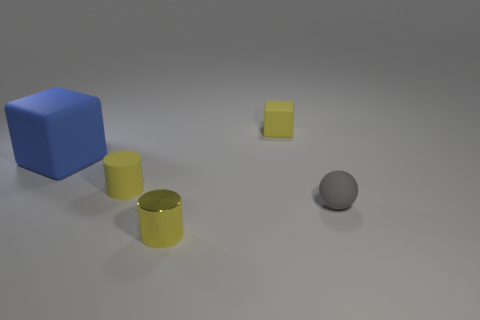The blue matte cube is what size?
Your answer should be very brief. Large. Are there more big things to the left of the tiny gray ball than big yellow cylinders?
Ensure brevity in your answer.  Yes. Are there the same number of tiny shiny things that are in front of the blue rubber block and shiny cylinders in front of the tiny matte ball?
Offer a terse response. Yes. The small thing that is both in front of the rubber cylinder and behind the metal cylinder is what color?
Keep it short and to the point. Gray. Are there any other things that have the same size as the blue block?
Provide a succinct answer. No. Are there more blue blocks that are behind the tiny metal thing than big rubber objects in front of the rubber sphere?
Your answer should be very brief. Yes. Is the size of the yellow cylinder in front of the gray matte sphere the same as the yellow block?
Offer a terse response. Yes. What number of matte objects are to the left of the small rubber cube to the right of the yellow cylinder that is behind the small gray matte ball?
Your answer should be compact. 2. There is a thing that is behind the small matte cylinder and in front of the small yellow cube; what is its size?
Provide a short and direct response. Large. What number of other things are there of the same shape as the yellow shiny thing?
Give a very brief answer. 1. 